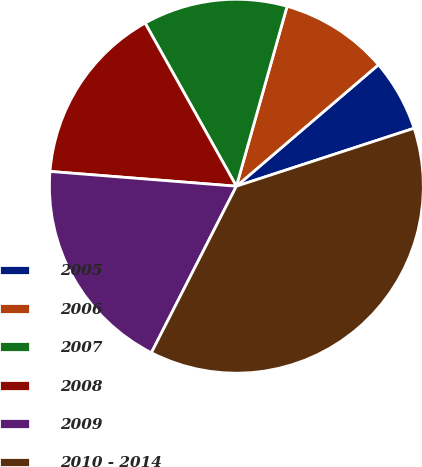Convert chart. <chart><loc_0><loc_0><loc_500><loc_500><pie_chart><fcel>2005<fcel>2006<fcel>2007<fcel>2008<fcel>2009<fcel>2010 - 2014<nl><fcel>6.24%<fcel>9.37%<fcel>12.49%<fcel>15.62%<fcel>18.75%<fcel>37.53%<nl></chart> 